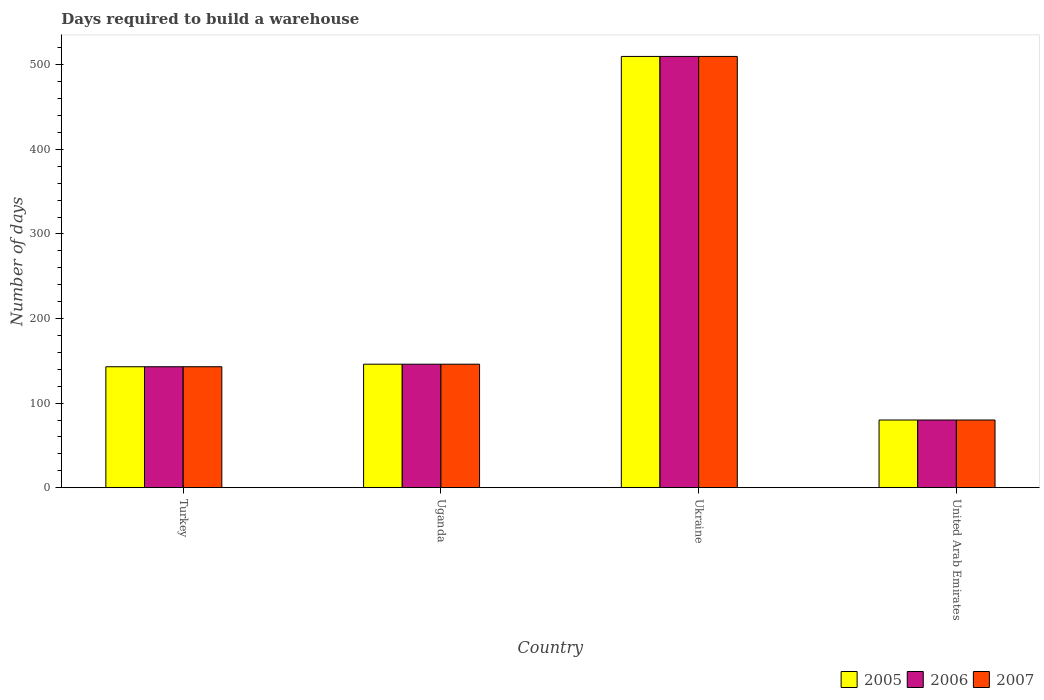How many different coloured bars are there?
Your answer should be very brief. 3. How many groups of bars are there?
Keep it short and to the point. 4. Are the number of bars per tick equal to the number of legend labels?
Offer a very short reply. Yes. Are the number of bars on each tick of the X-axis equal?
Keep it short and to the point. Yes. How many bars are there on the 4th tick from the left?
Offer a very short reply. 3. How many bars are there on the 2nd tick from the right?
Offer a very short reply. 3. What is the label of the 1st group of bars from the left?
Give a very brief answer. Turkey. What is the days required to build a warehouse in in 2005 in Turkey?
Give a very brief answer. 143. Across all countries, what is the maximum days required to build a warehouse in in 2007?
Your response must be concise. 510. In which country was the days required to build a warehouse in in 2007 maximum?
Your answer should be very brief. Ukraine. In which country was the days required to build a warehouse in in 2007 minimum?
Your answer should be compact. United Arab Emirates. What is the total days required to build a warehouse in in 2005 in the graph?
Offer a very short reply. 879. What is the difference between the days required to build a warehouse in in 2005 in Ukraine and that in United Arab Emirates?
Offer a very short reply. 430. What is the difference between the days required to build a warehouse in in 2005 in United Arab Emirates and the days required to build a warehouse in in 2007 in Turkey?
Offer a very short reply. -63. What is the average days required to build a warehouse in in 2005 per country?
Keep it short and to the point. 219.75. What is the difference between the days required to build a warehouse in of/in 2006 and days required to build a warehouse in of/in 2007 in Uganda?
Give a very brief answer. 0. In how many countries, is the days required to build a warehouse in in 2006 greater than 120 days?
Offer a very short reply. 3. What is the ratio of the days required to build a warehouse in in 2005 in Uganda to that in Ukraine?
Provide a succinct answer. 0.29. Is the days required to build a warehouse in in 2005 in Turkey less than that in Ukraine?
Ensure brevity in your answer.  Yes. What is the difference between the highest and the second highest days required to build a warehouse in in 2006?
Provide a short and direct response. -364. What is the difference between the highest and the lowest days required to build a warehouse in in 2006?
Your answer should be compact. 430. Is the sum of the days required to build a warehouse in in 2006 in Uganda and United Arab Emirates greater than the maximum days required to build a warehouse in in 2005 across all countries?
Make the answer very short. No. What does the 3rd bar from the left in Turkey represents?
Provide a succinct answer. 2007. Are all the bars in the graph horizontal?
Give a very brief answer. No. How many countries are there in the graph?
Give a very brief answer. 4. What is the difference between two consecutive major ticks on the Y-axis?
Your answer should be compact. 100. Does the graph contain any zero values?
Your response must be concise. No. Where does the legend appear in the graph?
Provide a short and direct response. Bottom right. How many legend labels are there?
Offer a terse response. 3. What is the title of the graph?
Your response must be concise. Days required to build a warehouse. Does "1977" appear as one of the legend labels in the graph?
Your answer should be very brief. No. What is the label or title of the Y-axis?
Provide a succinct answer. Number of days. What is the Number of days in 2005 in Turkey?
Make the answer very short. 143. What is the Number of days of 2006 in Turkey?
Provide a succinct answer. 143. What is the Number of days in 2007 in Turkey?
Provide a succinct answer. 143. What is the Number of days of 2005 in Uganda?
Give a very brief answer. 146. What is the Number of days in 2006 in Uganda?
Keep it short and to the point. 146. What is the Number of days in 2007 in Uganda?
Your answer should be very brief. 146. What is the Number of days of 2005 in Ukraine?
Ensure brevity in your answer.  510. What is the Number of days of 2006 in Ukraine?
Your response must be concise. 510. What is the Number of days in 2007 in Ukraine?
Give a very brief answer. 510. What is the Number of days of 2005 in United Arab Emirates?
Make the answer very short. 80. Across all countries, what is the maximum Number of days of 2005?
Offer a terse response. 510. Across all countries, what is the maximum Number of days of 2006?
Your response must be concise. 510. Across all countries, what is the maximum Number of days in 2007?
Your response must be concise. 510. Across all countries, what is the minimum Number of days in 2006?
Make the answer very short. 80. Across all countries, what is the minimum Number of days of 2007?
Your response must be concise. 80. What is the total Number of days in 2005 in the graph?
Ensure brevity in your answer.  879. What is the total Number of days in 2006 in the graph?
Keep it short and to the point. 879. What is the total Number of days of 2007 in the graph?
Your response must be concise. 879. What is the difference between the Number of days of 2005 in Turkey and that in Uganda?
Make the answer very short. -3. What is the difference between the Number of days in 2007 in Turkey and that in Uganda?
Ensure brevity in your answer.  -3. What is the difference between the Number of days in 2005 in Turkey and that in Ukraine?
Keep it short and to the point. -367. What is the difference between the Number of days of 2006 in Turkey and that in Ukraine?
Your answer should be compact. -367. What is the difference between the Number of days of 2007 in Turkey and that in Ukraine?
Your answer should be very brief. -367. What is the difference between the Number of days in 2005 in Turkey and that in United Arab Emirates?
Your answer should be compact. 63. What is the difference between the Number of days of 2006 in Turkey and that in United Arab Emirates?
Your answer should be very brief. 63. What is the difference between the Number of days in 2007 in Turkey and that in United Arab Emirates?
Give a very brief answer. 63. What is the difference between the Number of days in 2005 in Uganda and that in Ukraine?
Your answer should be very brief. -364. What is the difference between the Number of days of 2006 in Uganda and that in Ukraine?
Keep it short and to the point. -364. What is the difference between the Number of days of 2007 in Uganda and that in Ukraine?
Make the answer very short. -364. What is the difference between the Number of days in 2005 in Ukraine and that in United Arab Emirates?
Your answer should be compact. 430. What is the difference between the Number of days of 2006 in Ukraine and that in United Arab Emirates?
Provide a short and direct response. 430. What is the difference between the Number of days in 2007 in Ukraine and that in United Arab Emirates?
Provide a short and direct response. 430. What is the difference between the Number of days of 2005 in Turkey and the Number of days of 2006 in Uganda?
Your response must be concise. -3. What is the difference between the Number of days of 2005 in Turkey and the Number of days of 2007 in Uganda?
Keep it short and to the point. -3. What is the difference between the Number of days of 2005 in Turkey and the Number of days of 2006 in Ukraine?
Offer a terse response. -367. What is the difference between the Number of days of 2005 in Turkey and the Number of days of 2007 in Ukraine?
Provide a short and direct response. -367. What is the difference between the Number of days of 2006 in Turkey and the Number of days of 2007 in Ukraine?
Give a very brief answer. -367. What is the difference between the Number of days in 2005 in Turkey and the Number of days in 2006 in United Arab Emirates?
Offer a terse response. 63. What is the difference between the Number of days of 2005 in Uganda and the Number of days of 2006 in Ukraine?
Give a very brief answer. -364. What is the difference between the Number of days in 2005 in Uganda and the Number of days in 2007 in Ukraine?
Give a very brief answer. -364. What is the difference between the Number of days in 2006 in Uganda and the Number of days in 2007 in Ukraine?
Ensure brevity in your answer.  -364. What is the difference between the Number of days in 2005 in Uganda and the Number of days in 2007 in United Arab Emirates?
Your answer should be very brief. 66. What is the difference between the Number of days in 2006 in Uganda and the Number of days in 2007 in United Arab Emirates?
Provide a succinct answer. 66. What is the difference between the Number of days of 2005 in Ukraine and the Number of days of 2006 in United Arab Emirates?
Provide a succinct answer. 430. What is the difference between the Number of days of 2005 in Ukraine and the Number of days of 2007 in United Arab Emirates?
Offer a very short reply. 430. What is the difference between the Number of days in 2006 in Ukraine and the Number of days in 2007 in United Arab Emirates?
Give a very brief answer. 430. What is the average Number of days in 2005 per country?
Provide a short and direct response. 219.75. What is the average Number of days in 2006 per country?
Offer a very short reply. 219.75. What is the average Number of days of 2007 per country?
Make the answer very short. 219.75. What is the difference between the Number of days of 2005 and Number of days of 2007 in Uganda?
Give a very brief answer. 0. What is the difference between the Number of days of 2006 and Number of days of 2007 in Ukraine?
Your answer should be very brief. 0. What is the difference between the Number of days of 2005 and Number of days of 2006 in United Arab Emirates?
Keep it short and to the point. 0. What is the difference between the Number of days of 2006 and Number of days of 2007 in United Arab Emirates?
Provide a succinct answer. 0. What is the ratio of the Number of days in 2005 in Turkey to that in Uganda?
Offer a terse response. 0.98. What is the ratio of the Number of days in 2006 in Turkey to that in Uganda?
Provide a succinct answer. 0.98. What is the ratio of the Number of days in 2007 in Turkey to that in Uganda?
Make the answer very short. 0.98. What is the ratio of the Number of days of 2005 in Turkey to that in Ukraine?
Make the answer very short. 0.28. What is the ratio of the Number of days in 2006 in Turkey to that in Ukraine?
Keep it short and to the point. 0.28. What is the ratio of the Number of days of 2007 in Turkey to that in Ukraine?
Your answer should be very brief. 0.28. What is the ratio of the Number of days in 2005 in Turkey to that in United Arab Emirates?
Give a very brief answer. 1.79. What is the ratio of the Number of days of 2006 in Turkey to that in United Arab Emirates?
Ensure brevity in your answer.  1.79. What is the ratio of the Number of days in 2007 in Turkey to that in United Arab Emirates?
Provide a succinct answer. 1.79. What is the ratio of the Number of days of 2005 in Uganda to that in Ukraine?
Provide a succinct answer. 0.29. What is the ratio of the Number of days of 2006 in Uganda to that in Ukraine?
Make the answer very short. 0.29. What is the ratio of the Number of days in 2007 in Uganda to that in Ukraine?
Offer a very short reply. 0.29. What is the ratio of the Number of days in 2005 in Uganda to that in United Arab Emirates?
Your answer should be compact. 1.82. What is the ratio of the Number of days of 2006 in Uganda to that in United Arab Emirates?
Provide a short and direct response. 1.82. What is the ratio of the Number of days of 2007 in Uganda to that in United Arab Emirates?
Give a very brief answer. 1.82. What is the ratio of the Number of days of 2005 in Ukraine to that in United Arab Emirates?
Your response must be concise. 6.38. What is the ratio of the Number of days of 2006 in Ukraine to that in United Arab Emirates?
Offer a terse response. 6.38. What is the ratio of the Number of days of 2007 in Ukraine to that in United Arab Emirates?
Make the answer very short. 6.38. What is the difference between the highest and the second highest Number of days of 2005?
Your answer should be compact. 364. What is the difference between the highest and the second highest Number of days of 2006?
Offer a very short reply. 364. What is the difference between the highest and the second highest Number of days in 2007?
Offer a very short reply. 364. What is the difference between the highest and the lowest Number of days in 2005?
Make the answer very short. 430. What is the difference between the highest and the lowest Number of days in 2006?
Provide a succinct answer. 430. What is the difference between the highest and the lowest Number of days in 2007?
Keep it short and to the point. 430. 